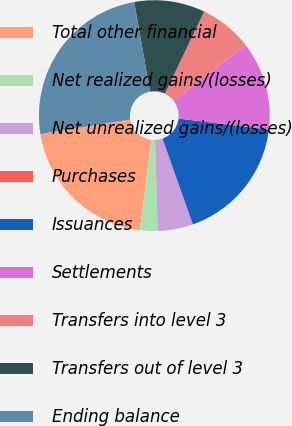Convert chart. <chart><loc_0><loc_0><loc_500><loc_500><pie_chart><fcel>Total other financial<fcel>Net realized gains/(losses)<fcel>Net unrealized gains/(losses)<fcel>Purchases<fcel>Issuances<fcel>Settlements<fcel>Transfers into level 3<fcel>Transfers out of level 3<fcel>Ending balance<nl><fcel>20.45%<fcel>2.48%<fcel>4.95%<fcel>0.0%<fcel>17.66%<fcel>12.38%<fcel>7.43%<fcel>9.9%<fcel>24.75%<nl></chart> 